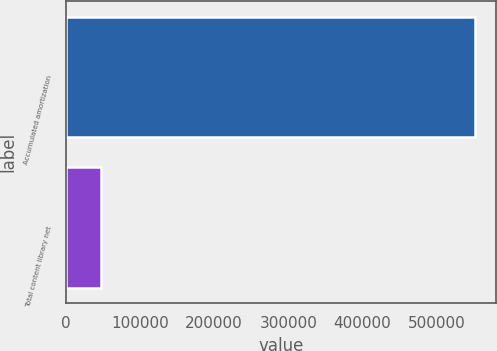<chart> <loc_0><loc_0><loc_500><loc_500><bar_chart><fcel>Accumulated amortization<fcel>Total content library net<nl><fcel>552526<fcel>46629<nl></chart> 